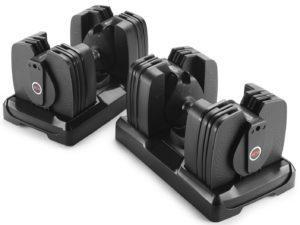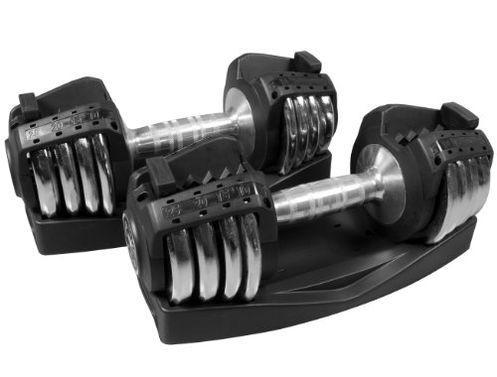The first image is the image on the left, the second image is the image on the right. Considering the images on both sides, is "There are four barbell stands." valid? Answer yes or no. Yes. The first image is the image on the left, the second image is the image on the right. For the images shown, is this caption "The left and right image contains a total of four dumbbells and four racks." true? Answer yes or no. Yes. 